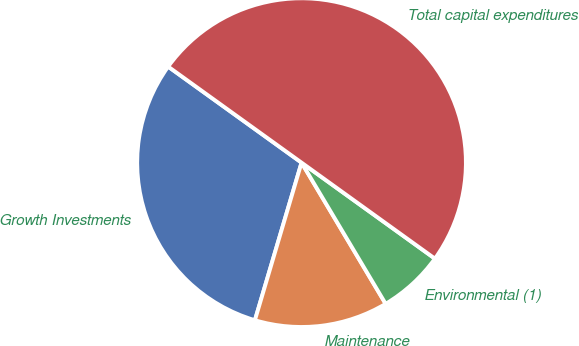<chart> <loc_0><loc_0><loc_500><loc_500><pie_chart><fcel>Growth Investments<fcel>Maintenance<fcel>Environmental (1)<fcel>Total capital expenditures<nl><fcel>30.35%<fcel>13.13%<fcel>6.52%<fcel>50.0%<nl></chart> 